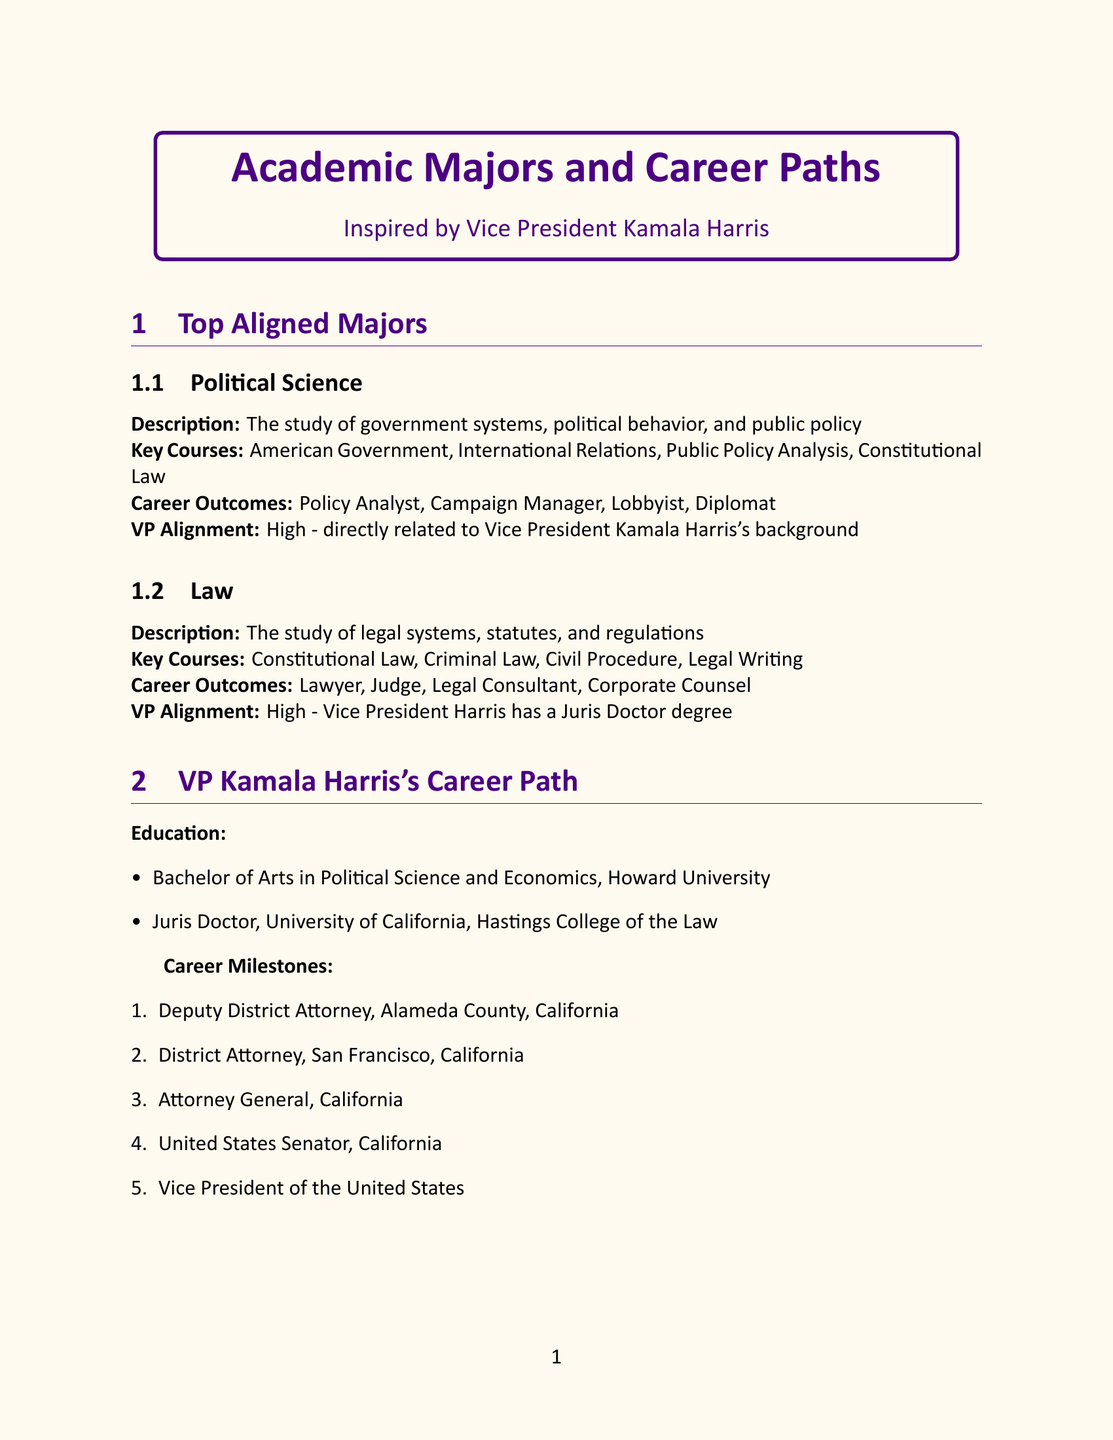What is the first academic major listed? The first academic major in the document is specified in the "Top Aligned Majors" section, which is Political Science.
Answer: Political Science What degree does Vice President Kamala Harris hold? According to her education details in the document, Vice President Kamala Harris holds a Juris Doctor degree.
Answer: Juris Doctor How many career milestones are listed for VP Kamala Harris? The document lists her career milestones in an enumerated format; there are five milestones presented.
Answer: 5 Which skill is described as critical for political careers? The document specifies public speaking as a skill that is critical for political careers and leadership roles.
Answer: Public Speaking What internship opportunity is related to civil rights? The ACLU offers a legal internship related to civil rights and constitutional law issues, as outlined in the internship opportunities section.
Answer: ACLU What is the alignment level of the Public Administration major with VP Harris's work? The alignment level for Public Administration in relation to Vice President Harris's work is mentioned as medium.
Answer: Medium Name one key course for the Economics major. The document lists key courses for the Economics major, one of which is Macroeconomics.
Answer: Macroeconomics Which organization offers a program to learn about local governance? The document mentions Local Government Offices offering a City Hall Internship program to learn about local governance and community engagement.
Answer: Local Government Offices 